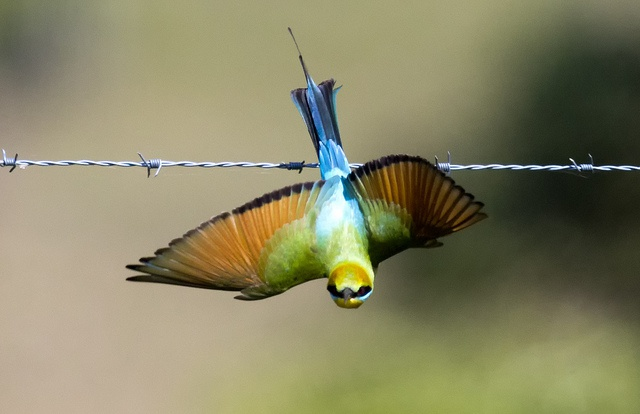Describe the objects in this image and their specific colors. I can see a bird in olive, black, and maroon tones in this image. 